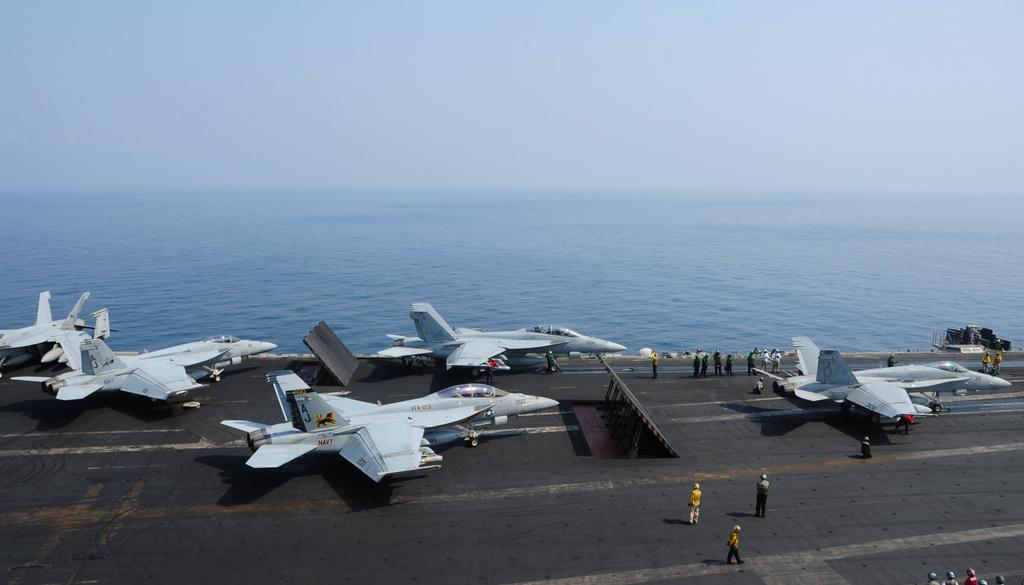What can be seen on the runway in the image? There are aeroplanes on the runway in the image. Are there any people present near the aeroplanes? Yes, there are people standing near the aeroplanes. What can be seen in the background of the image? Water is visible in the background of the image. What type of lock can be seen securing the steel door in the image? There is no steel door or lock present in the image; it features aeroplanes on a runway with people nearby and water in the background. 